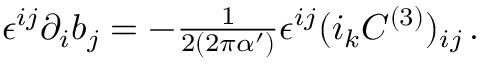Convert formula to latex. <formula><loc_0><loc_0><loc_500><loc_500>\epsilon ^ { i j } \partial _ { i } b _ { j } = - { \frac { 1 } { 2 ( 2 \pi \alpha ^ { \prime } ) } } \epsilon ^ { i j } ( i _ { k } C ^ { ( 3 ) } ) _ { i j } \, .</formula> 